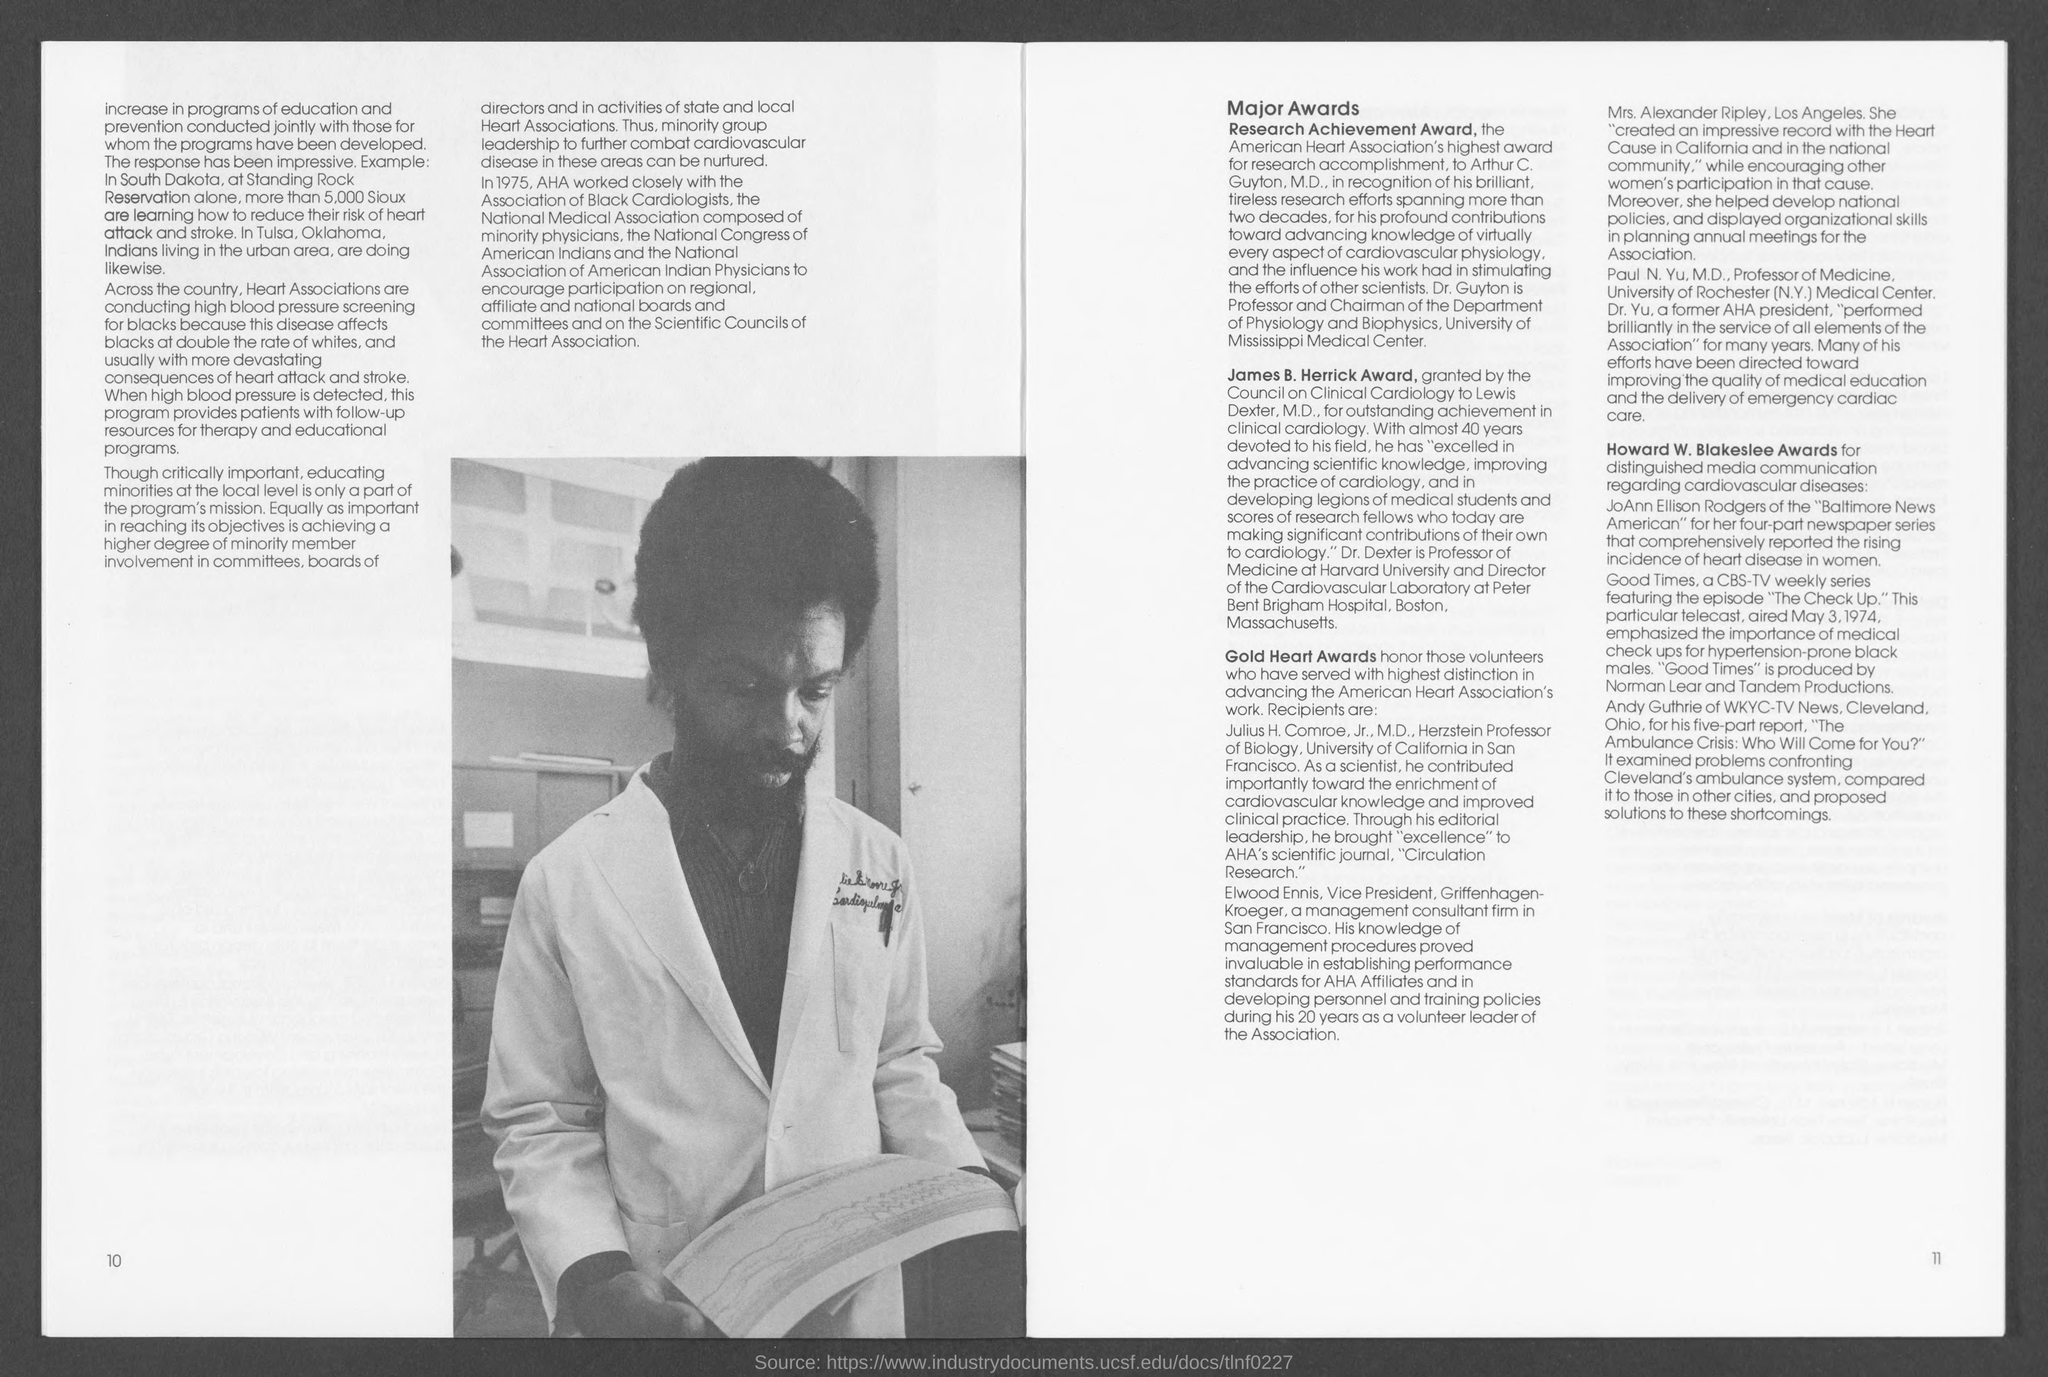Indicate a few pertinent items in this graphic. The number located in the bottom-right corner of the page is 11. The number located in the bottom-left corner of the page is 10. 